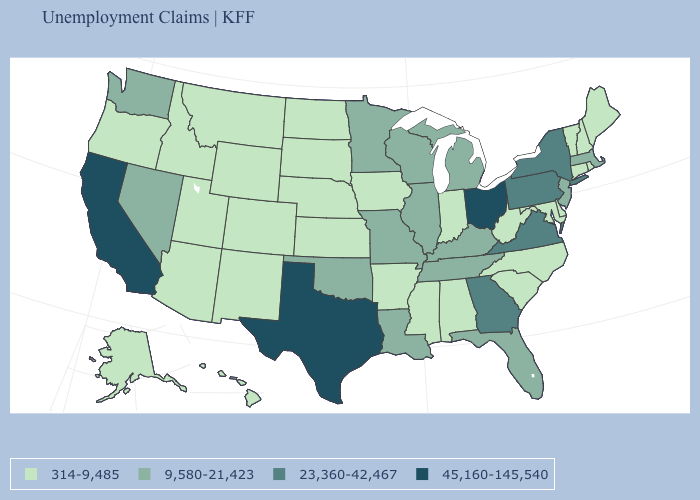What is the value of South Carolina?
Keep it brief. 314-9,485. What is the lowest value in states that border Montana?
Answer briefly. 314-9,485. Name the states that have a value in the range 9,580-21,423?
Be succinct. Florida, Illinois, Kentucky, Louisiana, Massachusetts, Michigan, Minnesota, Missouri, Nevada, New Jersey, Oklahoma, Tennessee, Washington, Wisconsin. What is the value of Maryland?
Write a very short answer. 314-9,485. Does Louisiana have the highest value in the USA?
Concise answer only. No. Among the states that border Illinois , does Wisconsin have the lowest value?
Give a very brief answer. No. What is the value of Indiana?
Be succinct. 314-9,485. Name the states that have a value in the range 23,360-42,467?
Be succinct. Georgia, New York, Pennsylvania, Virginia. What is the highest value in the USA?
Answer briefly. 45,160-145,540. What is the value of Virginia?
Short answer required. 23,360-42,467. Does Ohio have the highest value in the USA?
Be succinct. Yes. What is the value of Alabama?
Give a very brief answer. 314-9,485. Name the states that have a value in the range 45,160-145,540?
Short answer required. California, Ohio, Texas. Does Colorado have a lower value than Delaware?
Answer briefly. No. 